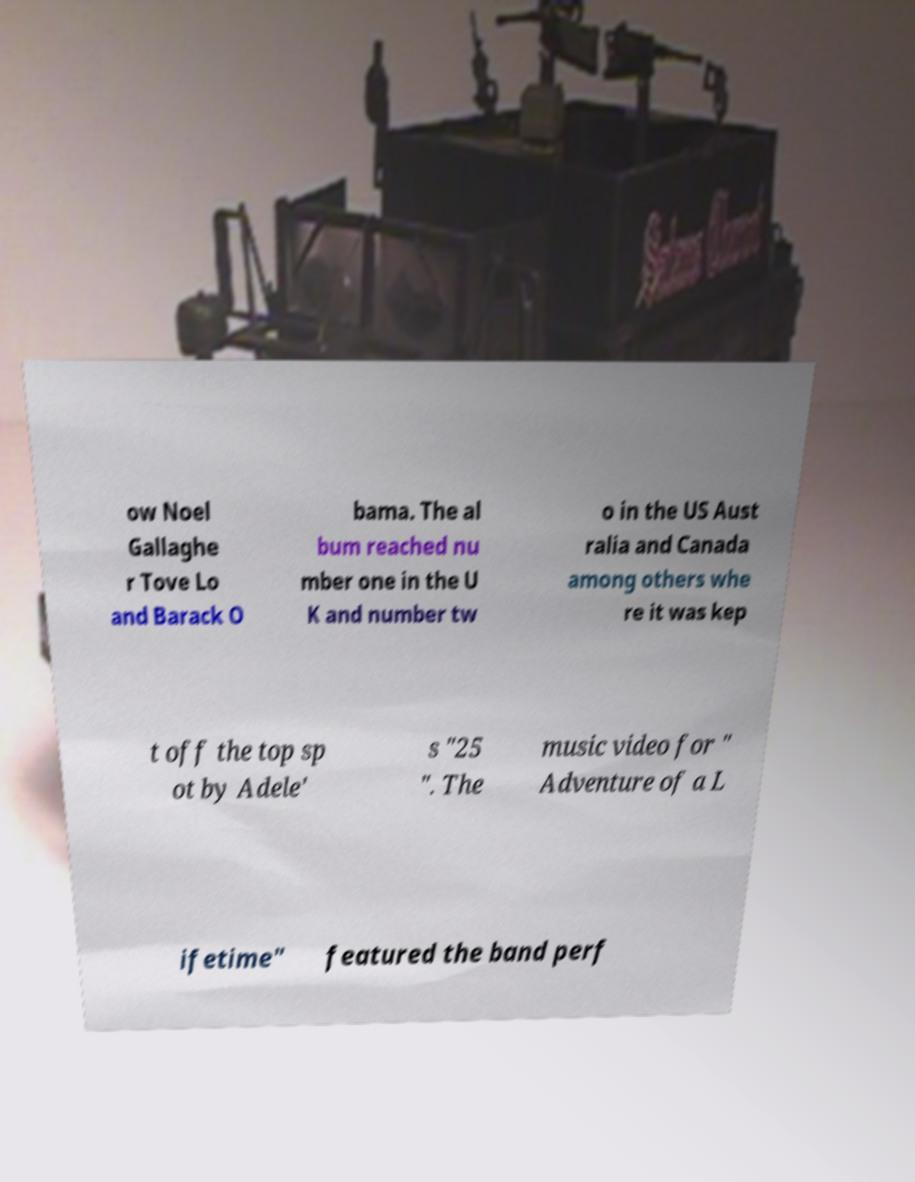Please read and relay the text visible in this image. What does it say? ow Noel Gallaghe r Tove Lo and Barack O bama. The al bum reached nu mber one in the U K and number tw o in the US Aust ralia and Canada among others whe re it was kep t off the top sp ot by Adele' s "25 ". The music video for " Adventure of a L ifetime" featured the band perf 